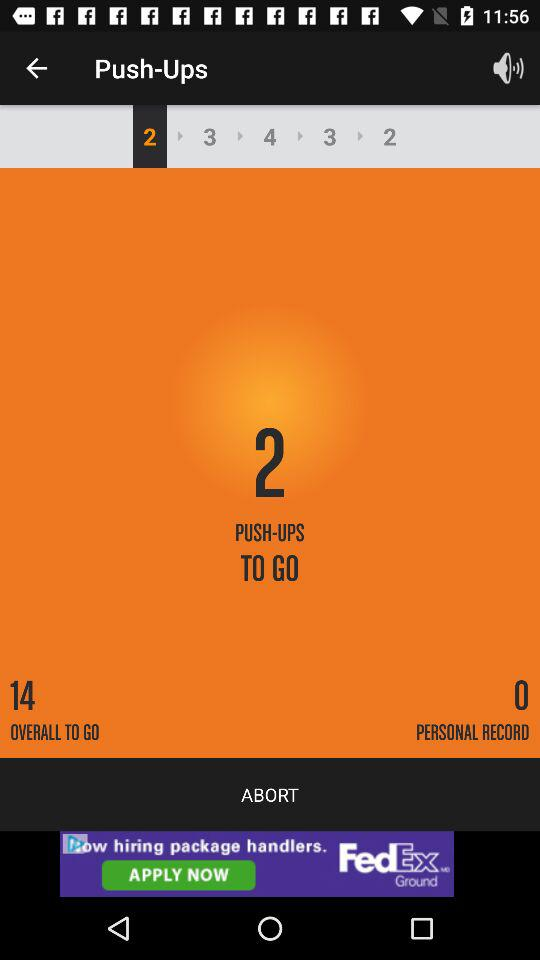What is the name of the exercise shown on the screen? The name of the exercise is push-ups. 